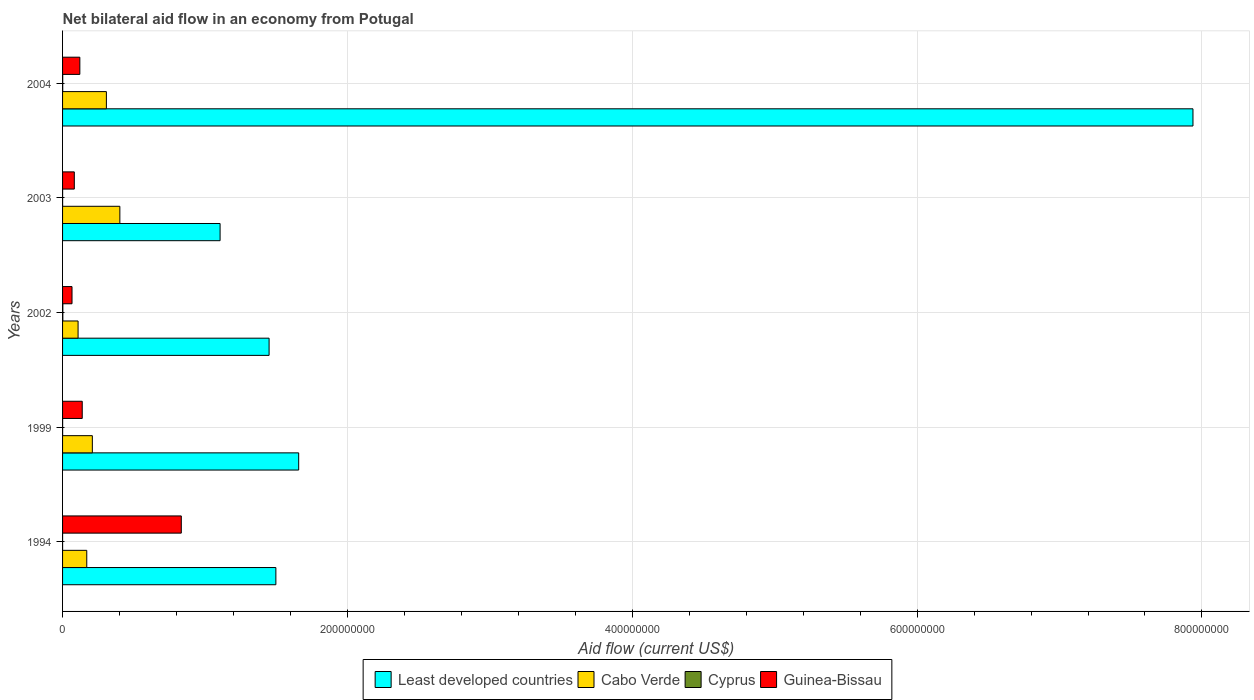How many groups of bars are there?
Give a very brief answer. 5. Are the number of bars per tick equal to the number of legend labels?
Ensure brevity in your answer.  Yes. Are the number of bars on each tick of the Y-axis equal?
Your answer should be very brief. Yes. How many bars are there on the 4th tick from the bottom?
Your response must be concise. 4. What is the label of the 1st group of bars from the top?
Provide a short and direct response. 2004. What is the net bilateral aid flow in Least developed countries in 2004?
Ensure brevity in your answer.  7.94e+08. Across all years, what is the maximum net bilateral aid flow in Cabo Verde?
Provide a short and direct response. 4.02e+07. Across all years, what is the minimum net bilateral aid flow in Least developed countries?
Make the answer very short. 1.11e+08. In which year was the net bilateral aid flow in Least developed countries maximum?
Your response must be concise. 2004. What is the difference between the net bilateral aid flow in Least developed countries in 2002 and that in 2003?
Give a very brief answer. 3.44e+07. What is the difference between the net bilateral aid flow in Guinea-Bissau in 1994 and the net bilateral aid flow in Least developed countries in 1999?
Your response must be concise. -8.24e+07. What is the average net bilateral aid flow in Least developed countries per year?
Keep it short and to the point. 2.73e+08. In the year 2002, what is the difference between the net bilateral aid flow in Guinea-Bissau and net bilateral aid flow in Cabo Verde?
Give a very brief answer. -4.25e+06. What is the ratio of the net bilateral aid flow in Cabo Verde in 1999 to that in 2003?
Provide a succinct answer. 0.52. Is the difference between the net bilateral aid flow in Guinea-Bissau in 1999 and 2003 greater than the difference between the net bilateral aid flow in Cabo Verde in 1999 and 2003?
Make the answer very short. Yes. What is the difference between the highest and the second highest net bilateral aid flow in Cyprus?
Make the answer very short. 8.00e+04. What is the difference between the highest and the lowest net bilateral aid flow in Guinea-Bissau?
Offer a very short reply. 7.67e+07. Is the sum of the net bilateral aid flow in Cabo Verde in 1999 and 2002 greater than the maximum net bilateral aid flow in Cyprus across all years?
Provide a short and direct response. Yes. Is it the case that in every year, the sum of the net bilateral aid flow in Least developed countries and net bilateral aid flow in Cyprus is greater than the sum of net bilateral aid flow in Guinea-Bissau and net bilateral aid flow in Cabo Verde?
Ensure brevity in your answer.  Yes. What does the 3rd bar from the top in 1999 represents?
Your answer should be compact. Cabo Verde. What does the 1st bar from the bottom in 2004 represents?
Provide a succinct answer. Least developed countries. Is it the case that in every year, the sum of the net bilateral aid flow in Cabo Verde and net bilateral aid flow in Cyprus is greater than the net bilateral aid flow in Least developed countries?
Provide a succinct answer. No. How many bars are there?
Offer a terse response. 20. Are all the bars in the graph horizontal?
Offer a terse response. Yes. How many years are there in the graph?
Provide a succinct answer. 5. Does the graph contain grids?
Your answer should be very brief. Yes. How are the legend labels stacked?
Ensure brevity in your answer.  Horizontal. What is the title of the graph?
Offer a terse response. Net bilateral aid flow in an economy from Potugal. Does "Cambodia" appear as one of the legend labels in the graph?
Keep it short and to the point. No. What is the label or title of the X-axis?
Make the answer very short. Aid flow (current US$). What is the label or title of the Y-axis?
Ensure brevity in your answer.  Years. What is the Aid flow (current US$) in Least developed countries in 1994?
Offer a very short reply. 1.50e+08. What is the Aid flow (current US$) of Cabo Verde in 1994?
Your response must be concise. 1.70e+07. What is the Aid flow (current US$) of Cyprus in 1994?
Provide a succinct answer. 10000. What is the Aid flow (current US$) in Guinea-Bissau in 1994?
Make the answer very short. 8.34e+07. What is the Aid flow (current US$) of Least developed countries in 1999?
Provide a succinct answer. 1.66e+08. What is the Aid flow (current US$) in Cabo Verde in 1999?
Make the answer very short. 2.09e+07. What is the Aid flow (current US$) in Cyprus in 1999?
Your response must be concise. 4.00e+04. What is the Aid flow (current US$) of Guinea-Bissau in 1999?
Keep it short and to the point. 1.38e+07. What is the Aid flow (current US$) of Least developed countries in 2002?
Ensure brevity in your answer.  1.45e+08. What is the Aid flow (current US$) in Cabo Verde in 2002?
Keep it short and to the point. 1.09e+07. What is the Aid flow (current US$) of Guinea-Bissau in 2002?
Your answer should be compact. 6.64e+06. What is the Aid flow (current US$) in Least developed countries in 2003?
Your response must be concise. 1.11e+08. What is the Aid flow (current US$) in Cabo Verde in 2003?
Keep it short and to the point. 4.02e+07. What is the Aid flow (current US$) in Cyprus in 2003?
Your answer should be very brief. 3.00e+04. What is the Aid flow (current US$) in Guinea-Bissau in 2003?
Your answer should be very brief. 8.25e+06. What is the Aid flow (current US$) in Least developed countries in 2004?
Make the answer very short. 7.94e+08. What is the Aid flow (current US$) of Cabo Verde in 2004?
Provide a succinct answer. 3.08e+07. What is the Aid flow (current US$) of Cyprus in 2004?
Your answer should be compact. 1.10e+05. What is the Aid flow (current US$) in Guinea-Bissau in 2004?
Your answer should be very brief. 1.21e+07. Across all years, what is the maximum Aid flow (current US$) in Least developed countries?
Provide a succinct answer. 7.94e+08. Across all years, what is the maximum Aid flow (current US$) in Cabo Verde?
Provide a succinct answer. 4.02e+07. Across all years, what is the maximum Aid flow (current US$) of Guinea-Bissau?
Your answer should be very brief. 8.34e+07. Across all years, what is the minimum Aid flow (current US$) in Least developed countries?
Provide a succinct answer. 1.11e+08. Across all years, what is the minimum Aid flow (current US$) in Cabo Verde?
Make the answer very short. 1.09e+07. Across all years, what is the minimum Aid flow (current US$) in Cyprus?
Provide a short and direct response. 10000. Across all years, what is the minimum Aid flow (current US$) of Guinea-Bissau?
Offer a very short reply. 6.64e+06. What is the total Aid flow (current US$) of Least developed countries in the graph?
Offer a terse response. 1.36e+09. What is the total Aid flow (current US$) of Cabo Verde in the graph?
Your response must be concise. 1.20e+08. What is the total Aid flow (current US$) in Cyprus in the graph?
Provide a short and direct response. 3.80e+05. What is the total Aid flow (current US$) of Guinea-Bissau in the graph?
Offer a terse response. 1.24e+08. What is the difference between the Aid flow (current US$) in Least developed countries in 1994 and that in 1999?
Provide a succinct answer. -1.60e+07. What is the difference between the Aid flow (current US$) in Cabo Verde in 1994 and that in 1999?
Make the answer very short. -3.92e+06. What is the difference between the Aid flow (current US$) in Guinea-Bissau in 1994 and that in 1999?
Your answer should be compact. 6.96e+07. What is the difference between the Aid flow (current US$) of Least developed countries in 1994 and that in 2002?
Provide a short and direct response. 4.76e+06. What is the difference between the Aid flow (current US$) in Cabo Verde in 1994 and that in 2002?
Offer a terse response. 6.10e+06. What is the difference between the Aid flow (current US$) of Cyprus in 1994 and that in 2002?
Provide a succinct answer. -1.80e+05. What is the difference between the Aid flow (current US$) in Guinea-Bissau in 1994 and that in 2002?
Keep it short and to the point. 7.67e+07. What is the difference between the Aid flow (current US$) in Least developed countries in 1994 and that in 2003?
Offer a very short reply. 3.92e+07. What is the difference between the Aid flow (current US$) in Cabo Verde in 1994 and that in 2003?
Provide a short and direct response. -2.32e+07. What is the difference between the Aid flow (current US$) of Guinea-Bissau in 1994 and that in 2003?
Give a very brief answer. 7.51e+07. What is the difference between the Aid flow (current US$) in Least developed countries in 1994 and that in 2004?
Ensure brevity in your answer.  -6.44e+08. What is the difference between the Aid flow (current US$) of Cabo Verde in 1994 and that in 2004?
Give a very brief answer. -1.38e+07. What is the difference between the Aid flow (current US$) of Guinea-Bissau in 1994 and that in 2004?
Offer a very short reply. 7.12e+07. What is the difference between the Aid flow (current US$) of Least developed countries in 1999 and that in 2002?
Offer a terse response. 2.08e+07. What is the difference between the Aid flow (current US$) in Cabo Verde in 1999 and that in 2002?
Give a very brief answer. 1.00e+07. What is the difference between the Aid flow (current US$) of Cyprus in 1999 and that in 2002?
Offer a terse response. -1.50e+05. What is the difference between the Aid flow (current US$) of Guinea-Bissau in 1999 and that in 2002?
Offer a very short reply. 7.17e+06. What is the difference between the Aid flow (current US$) of Least developed countries in 1999 and that in 2003?
Make the answer very short. 5.52e+07. What is the difference between the Aid flow (current US$) in Cabo Verde in 1999 and that in 2003?
Offer a very short reply. -1.93e+07. What is the difference between the Aid flow (current US$) in Guinea-Bissau in 1999 and that in 2003?
Make the answer very short. 5.56e+06. What is the difference between the Aid flow (current US$) of Least developed countries in 1999 and that in 2004?
Offer a very short reply. -6.28e+08. What is the difference between the Aid flow (current US$) in Cabo Verde in 1999 and that in 2004?
Ensure brevity in your answer.  -9.86e+06. What is the difference between the Aid flow (current US$) of Cyprus in 1999 and that in 2004?
Keep it short and to the point. -7.00e+04. What is the difference between the Aid flow (current US$) of Guinea-Bissau in 1999 and that in 2004?
Offer a terse response. 1.68e+06. What is the difference between the Aid flow (current US$) in Least developed countries in 2002 and that in 2003?
Keep it short and to the point. 3.44e+07. What is the difference between the Aid flow (current US$) in Cabo Verde in 2002 and that in 2003?
Your answer should be very brief. -2.93e+07. What is the difference between the Aid flow (current US$) in Cyprus in 2002 and that in 2003?
Make the answer very short. 1.60e+05. What is the difference between the Aid flow (current US$) of Guinea-Bissau in 2002 and that in 2003?
Your response must be concise. -1.61e+06. What is the difference between the Aid flow (current US$) of Least developed countries in 2002 and that in 2004?
Your answer should be compact. -6.49e+08. What is the difference between the Aid flow (current US$) in Cabo Verde in 2002 and that in 2004?
Your answer should be very brief. -1.99e+07. What is the difference between the Aid flow (current US$) in Cyprus in 2002 and that in 2004?
Give a very brief answer. 8.00e+04. What is the difference between the Aid flow (current US$) of Guinea-Bissau in 2002 and that in 2004?
Your answer should be very brief. -5.49e+06. What is the difference between the Aid flow (current US$) in Least developed countries in 2003 and that in 2004?
Offer a terse response. -6.83e+08. What is the difference between the Aid flow (current US$) in Cabo Verde in 2003 and that in 2004?
Ensure brevity in your answer.  9.46e+06. What is the difference between the Aid flow (current US$) of Cyprus in 2003 and that in 2004?
Provide a succinct answer. -8.00e+04. What is the difference between the Aid flow (current US$) of Guinea-Bissau in 2003 and that in 2004?
Keep it short and to the point. -3.88e+06. What is the difference between the Aid flow (current US$) of Least developed countries in 1994 and the Aid flow (current US$) of Cabo Verde in 1999?
Provide a short and direct response. 1.29e+08. What is the difference between the Aid flow (current US$) of Least developed countries in 1994 and the Aid flow (current US$) of Cyprus in 1999?
Keep it short and to the point. 1.50e+08. What is the difference between the Aid flow (current US$) of Least developed countries in 1994 and the Aid flow (current US$) of Guinea-Bissau in 1999?
Offer a terse response. 1.36e+08. What is the difference between the Aid flow (current US$) of Cabo Verde in 1994 and the Aid flow (current US$) of Cyprus in 1999?
Your answer should be very brief. 1.70e+07. What is the difference between the Aid flow (current US$) of Cabo Verde in 1994 and the Aid flow (current US$) of Guinea-Bissau in 1999?
Your response must be concise. 3.18e+06. What is the difference between the Aid flow (current US$) of Cyprus in 1994 and the Aid flow (current US$) of Guinea-Bissau in 1999?
Your answer should be very brief. -1.38e+07. What is the difference between the Aid flow (current US$) of Least developed countries in 1994 and the Aid flow (current US$) of Cabo Verde in 2002?
Keep it short and to the point. 1.39e+08. What is the difference between the Aid flow (current US$) in Least developed countries in 1994 and the Aid flow (current US$) in Cyprus in 2002?
Your answer should be compact. 1.50e+08. What is the difference between the Aid flow (current US$) in Least developed countries in 1994 and the Aid flow (current US$) in Guinea-Bissau in 2002?
Provide a succinct answer. 1.43e+08. What is the difference between the Aid flow (current US$) in Cabo Verde in 1994 and the Aid flow (current US$) in Cyprus in 2002?
Your answer should be compact. 1.68e+07. What is the difference between the Aid flow (current US$) in Cabo Verde in 1994 and the Aid flow (current US$) in Guinea-Bissau in 2002?
Give a very brief answer. 1.04e+07. What is the difference between the Aid flow (current US$) of Cyprus in 1994 and the Aid flow (current US$) of Guinea-Bissau in 2002?
Make the answer very short. -6.63e+06. What is the difference between the Aid flow (current US$) of Least developed countries in 1994 and the Aid flow (current US$) of Cabo Verde in 2003?
Your response must be concise. 1.10e+08. What is the difference between the Aid flow (current US$) of Least developed countries in 1994 and the Aid flow (current US$) of Cyprus in 2003?
Give a very brief answer. 1.50e+08. What is the difference between the Aid flow (current US$) in Least developed countries in 1994 and the Aid flow (current US$) in Guinea-Bissau in 2003?
Your answer should be very brief. 1.42e+08. What is the difference between the Aid flow (current US$) in Cabo Verde in 1994 and the Aid flow (current US$) in Cyprus in 2003?
Keep it short and to the point. 1.70e+07. What is the difference between the Aid flow (current US$) in Cabo Verde in 1994 and the Aid flow (current US$) in Guinea-Bissau in 2003?
Your response must be concise. 8.74e+06. What is the difference between the Aid flow (current US$) of Cyprus in 1994 and the Aid flow (current US$) of Guinea-Bissau in 2003?
Ensure brevity in your answer.  -8.24e+06. What is the difference between the Aid flow (current US$) of Least developed countries in 1994 and the Aid flow (current US$) of Cabo Verde in 2004?
Your answer should be compact. 1.19e+08. What is the difference between the Aid flow (current US$) in Least developed countries in 1994 and the Aid flow (current US$) in Cyprus in 2004?
Make the answer very short. 1.50e+08. What is the difference between the Aid flow (current US$) in Least developed countries in 1994 and the Aid flow (current US$) in Guinea-Bissau in 2004?
Your answer should be very brief. 1.38e+08. What is the difference between the Aid flow (current US$) in Cabo Verde in 1994 and the Aid flow (current US$) in Cyprus in 2004?
Offer a terse response. 1.69e+07. What is the difference between the Aid flow (current US$) in Cabo Verde in 1994 and the Aid flow (current US$) in Guinea-Bissau in 2004?
Offer a terse response. 4.86e+06. What is the difference between the Aid flow (current US$) in Cyprus in 1994 and the Aid flow (current US$) in Guinea-Bissau in 2004?
Your answer should be very brief. -1.21e+07. What is the difference between the Aid flow (current US$) in Least developed countries in 1999 and the Aid flow (current US$) in Cabo Verde in 2002?
Ensure brevity in your answer.  1.55e+08. What is the difference between the Aid flow (current US$) of Least developed countries in 1999 and the Aid flow (current US$) of Cyprus in 2002?
Make the answer very short. 1.66e+08. What is the difference between the Aid flow (current US$) of Least developed countries in 1999 and the Aid flow (current US$) of Guinea-Bissau in 2002?
Keep it short and to the point. 1.59e+08. What is the difference between the Aid flow (current US$) of Cabo Verde in 1999 and the Aid flow (current US$) of Cyprus in 2002?
Offer a very short reply. 2.07e+07. What is the difference between the Aid flow (current US$) in Cabo Verde in 1999 and the Aid flow (current US$) in Guinea-Bissau in 2002?
Ensure brevity in your answer.  1.43e+07. What is the difference between the Aid flow (current US$) of Cyprus in 1999 and the Aid flow (current US$) of Guinea-Bissau in 2002?
Keep it short and to the point. -6.60e+06. What is the difference between the Aid flow (current US$) in Least developed countries in 1999 and the Aid flow (current US$) in Cabo Verde in 2003?
Keep it short and to the point. 1.26e+08. What is the difference between the Aid flow (current US$) of Least developed countries in 1999 and the Aid flow (current US$) of Cyprus in 2003?
Offer a terse response. 1.66e+08. What is the difference between the Aid flow (current US$) of Least developed countries in 1999 and the Aid flow (current US$) of Guinea-Bissau in 2003?
Your answer should be compact. 1.58e+08. What is the difference between the Aid flow (current US$) of Cabo Verde in 1999 and the Aid flow (current US$) of Cyprus in 2003?
Your answer should be very brief. 2.09e+07. What is the difference between the Aid flow (current US$) of Cabo Verde in 1999 and the Aid flow (current US$) of Guinea-Bissau in 2003?
Offer a terse response. 1.27e+07. What is the difference between the Aid flow (current US$) of Cyprus in 1999 and the Aid flow (current US$) of Guinea-Bissau in 2003?
Give a very brief answer. -8.21e+06. What is the difference between the Aid flow (current US$) in Least developed countries in 1999 and the Aid flow (current US$) in Cabo Verde in 2004?
Ensure brevity in your answer.  1.35e+08. What is the difference between the Aid flow (current US$) in Least developed countries in 1999 and the Aid flow (current US$) in Cyprus in 2004?
Offer a very short reply. 1.66e+08. What is the difference between the Aid flow (current US$) in Least developed countries in 1999 and the Aid flow (current US$) in Guinea-Bissau in 2004?
Make the answer very short. 1.54e+08. What is the difference between the Aid flow (current US$) in Cabo Verde in 1999 and the Aid flow (current US$) in Cyprus in 2004?
Ensure brevity in your answer.  2.08e+07. What is the difference between the Aid flow (current US$) of Cabo Verde in 1999 and the Aid flow (current US$) of Guinea-Bissau in 2004?
Make the answer very short. 8.78e+06. What is the difference between the Aid flow (current US$) in Cyprus in 1999 and the Aid flow (current US$) in Guinea-Bissau in 2004?
Make the answer very short. -1.21e+07. What is the difference between the Aid flow (current US$) in Least developed countries in 2002 and the Aid flow (current US$) in Cabo Verde in 2003?
Make the answer very short. 1.05e+08. What is the difference between the Aid flow (current US$) of Least developed countries in 2002 and the Aid flow (current US$) of Cyprus in 2003?
Provide a short and direct response. 1.45e+08. What is the difference between the Aid flow (current US$) in Least developed countries in 2002 and the Aid flow (current US$) in Guinea-Bissau in 2003?
Provide a short and direct response. 1.37e+08. What is the difference between the Aid flow (current US$) of Cabo Verde in 2002 and the Aid flow (current US$) of Cyprus in 2003?
Provide a succinct answer. 1.09e+07. What is the difference between the Aid flow (current US$) of Cabo Verde in 2002 and the Aid flow (current US$) of Guinea-Bissau in 2003?
Make the answer very short. 2.64e+06. What is the difference between the Aid flow (current US$) in Cyprus in 2002 and the Aid flow (current US$) in Guinea-Bissau in 2003?
Give a very brief answer. -8.06e+06. What is the difference between the Aid flow (current US$) in Least developed countries in 2002 and the Aid flow (current US$) in Cabo Verde in 2004?
Your response must be concise. 1.14e+08. What is the difference between the Aid flow (current US$) of Least developed countries in 2002 and the Aid flow (current US$) of Cyprus in 2004?
Your answer should be compact. 1.45e+08. What is the difference between the Aid flow (current US$) in Least developed countries in 2002 and the Aid flow (current US$) in Guinea-Bissau in 2004?
Offer a very short reply. 1.33e+08. What is the difference between the Aid flow (current US$) of Cabo Verde in 2002 and the Aid flow (current US$) of Cyprus in 2004?
Make the answer very short. 1.08e+07. What is the difference between the Aid flow (current US$) in Cabo Verde in 2002 and the Aid flow (current US$) in Guinea-Bissau in 2004?
Ensure brevity in your answer.  -1.24e+06. What is the difference between the Aid flow (current US$) in Cyprus in 2002 and the Aid flow (current US$) in Guinea-Bissau in 2004?
Ensure brevity in your answer.  -1.19e+07. What is the difference between the Aid flow (current US$) of Least developed countries in 2003 and the Aid flow (current US$) of Cabo Verde in 2004?
Make the answer very short. 7.98e+07. What is the difference between the Aid flow (current US$) of Least developed countries in 2003 and the Aid flow (current US$) of Cyprus in 2004?
Keep it short and to the point. 1.10e+08. What is the difference between the Aid flow (current US$) in Least developed countries in 2003 and the Aid flow (current US$) in Guinea-Bissau in 2004?
Give a very brief answer. 9.85e+07. What is the difference between the Aid flow (current US$) in Cabo Verde in 2003 and the Aid flow (current US$) in Cyprus in 2004?
Provide a short and direct response. 4.01e+07. What is the difference between the Aid flow (current US$) in Cabo Verde in 2003 and the Aid flow (current US$) in Guinea-Bissau in 2004?
Give a very brief answer. 2.81e+07. What is the difference between the Aid flow (current US$) in Cyprus in 2003 and the Aid flow (current US$) in Guinea-Bissau in 2004?
Give a very brief answer. -1.21e+07. What is the average Aid flow (current US$) of Least developed countries per year?
Provide a short and direct response. 2.73e+08. What is the average Aid flow (current US$) of Cabo Verde per year?
Provide a short and direct response. 2.40e+07. What is the average Aid flow (current US$) of Cyprus per year?
Offer a very short reply. 7.60e+04. What is the average Aid flow (current US$) of Guinea-Bissau per year?
Ensure brevity in your answer.  2.48e+07. In the year 1994, what is the difference between the Aid flow (current US$) in Least developed countries and Aid flow (current US$) in Cabo Verde?
Make the answer very short. 1.33e+08. In the year 1994, what is the difference between the Aid flow (current US$) of Least developed countries and Aid flow (current US$) of Cyprus?
Your answer should be compact. 1.50e+08. In the year 1994, what is the difference between the Aid flow (current US$) in Least developed countries and Aid flow (current US$) in Guinea-Bissau?
Make the answer very short. 6.64e+07. In the year 1994, what is the difference between the Aid flow (current US$) of Cabo Verde and Aid flow (current US$) of Cyprus?
Provide a succinct answer. 1.70e+07. In the year 1994, what is the difference between the Aid flow (current US$) of Cabo Verde and Aid flow (current US$) of Guinea-Bissau?
Your response must be concise. -6.64e+07. In the year 1994, what is the difference between the Aid flow (current US$) of Cyprus and Aid flow (current US$) of Guinea-Bissau?
Keep it short and to the point. -8.34e+07. In the year 1999, what is the difference between the Aid flow (current US$) in Least developed countries and Aid flow (current US$) in Cabo Verde?
Keep it short and to the point. 1.45e+08. In the year 1999, what is the difference between the Aid flow (current US$) in Least developed countries and Aid flow (current US$) in Cyprus?
Your response must be concise. 1.66e+08. In the year 1999, what is the difference between the Aid flow (current US$) in Least developed countries and Aid flow (current US$) in Guinea-Bissau?
Keep it short and to the point. 1.52e+08. In the year 1999, what is the difference between the Aid flow (current US$) of Cabo Verde and Aid flow (current US$) of Cyprus?
Your answer should be compact. 2.09e+07. In the year 1999, what is the difference between the Aid flow (current US$) of Cabo Verde and Aid flow (current US$) of Guinea-Bissau?
Offer a terse response. 7.10e+06. In the year 1999, what is the difference between the Aid flow (current US$) of Cyprus and Aid flow (current US$) of Guinea-Bissau?
Offer a very short reply. -1.38e+07. In the year 2002, what is the difference between the Aid flow (current US$) in Least developed countries and Aid flow (current US$) in Cabo Verde?
Make the answer very short. 1.34e+08. In the year 2002, what is the difference between the Aid flow (current US$) in Least developed countries and Aid flow (current US$) in Cyprus?
Offer a terse response. 1.45e+08. In the year 2002, what is the difference between the Aid flow (current US$) in Least developed countries and Aid flow (current US$) in Guinea-Bissau?
Ensure brevity in your answer.  1.38e+08. In the year 2002, what is the difference between the Aid flow (current US$) in Cabo Verde and Aid flow (current US$) in Cyprus?
Make the answer very short. 1.07e+07. In the year 2002, what is the difference between the Aid flow (current US$) in Cabo Verde and Aid flow (current US$) in Guinea-Bissau?
Provide a short and direct response. 4.25e+06. In the year 2002, what is the difference between the Aid flow (current US$) in Cyprus and Aid flow (current US$) in Guinea-Bissau?
Your answer should be compact. -6.45e+06. In the year 2003, what is the difference between the Aid flow (current US$) of Least developed countries and Aid flow (current US$) of Cabo Verde?
Provide a short and direct response. 7.04e+07. In the year 2003, what is the difference between the Aid flow (current US$) of Least developed countries and Aid flow (current US$) of Cyprus?
Make the answer very short. 1.11e+08. In the year 2003, what is the difference between the Aid flow (current US$) of Least developed countries and Aid flow (current US$) of Guinea-Bissau?
Make the answer very short. 1.02e+08. In the year 2003, what is the difference between the Aid flow (current US$) in Cabo Verde and Aid flow (current US$) in Cyprus?
Give a very brief answer. 4.02e+07. In the year 2003, what is the difference between the Aid flow (current US$) of Cabo Verde and Aid flow (current US$) of Guinea-Bissau?
Keep it short and to the point. 3.20e+07. In the year 2003, what is the difference between the Aid flow (current US$) in Cyprus and Aid flow (current US$) in Guinea-Bissau?
Keep it short and to the point. -8.22e+06. In the year 2004, what is the difference between the Aid flow (current US$) of Least developed countries and Aid flow (current US$) of Cabo Verde?
Your answer should be very brief. 7.63e+08. In the year 2004, what is the difference between the Aid flow (current US$) of Least developed countries and Aid flow (current US$) of Cyprus?
Your response must be concise. 7.94e+08. In the year 2004, what is the difference between the Aid flow (current US$) in Least developed countries and Aid flow (current US$) in Guinea-Bissau?
Make the answer very short. 7.82e+08. In the year 2004, what is the difference between the Aid flow (current US$) in Cabo Verde and Aid flow (current US$) in Cyprus?
Offer a very short reply. 3.07e+07. In the year 2004, what is the difference between the Aid flow (current US$) of Cabo Verde and Aid flow (current US$) of Guinea-Bissau?
Ensure brevity in your answer.  1.86e+07. In the year 2004, what is the difference between the Aid flow (current US$) in Cyprus and Aid flow (current US$) in Guinea-Bissau?
Ensure brevity in your answer.  -1.20e+07. What is the ratio of the Aid flow (current US$) of Least developed countries in 1994 to that in 1999?
Your answer should be compact. 0.9. What is the ratio of the Aid flow (current US$) of Cabo Verde in 1994 to that in 1999?
Provide a succinct answer. 0.81. What is the ratio of the Aid flow (current US$) of Cyprus in 1994 to that in 1999?
Give a very brief answer. 0.25. What is the ratio of the Aid flow (current US$) in Guinea-Bissau in 1994 to that in 1999?
Provide a succinct answer. 6.04. What is the ratio of the Aid flow (current US$) of Least developed countries in 1994 to that in 2002?
Keep it short and to the point. 1.03. What is the ratio of the Aid flow (current US$) of Cabo Verde in 1994 to that in 2002?
Keep it short and to the point. 1.56. What is the ratio of the Aid flow (current US$) in Cyprus in 1994 to that in 2002?
Your answer should be very brief. 0.05. What is the ratio of the Aid flow (current US$) of Guinea-Bissau in 1994 to that in 2002?
Provide a succinct answer. 12.56. What is the ratio of the Aid flow (current US$) of Least developed countries in 1994 to that in 2003?
Give a very brief answer. 1.35. What is the ratio of the Aid flow (current US$) of Cabo Verde in 1994 to that in 2003?
Your answer should be very brief. 0.42. What is the ratio of the Aid flow (current US$) in Cyprus in 1994 to that in 2003?
Your response must be concise. 0.33. What is the ratio of the Aid flow (current US$) in Guinea-Bissau in 1994 to that in 2003?
Give a very brief answer. 10.11. What is the ratio of the Aid flow (current US$) of Least developed countries in 1994 to that in 2004?
Ensure brevity in your answer.  0.19. What is the ratio of the Aid flow (current US$) in Cabo Verde in 1994 to that in 2004?
Your answer should be compact. 0.55. What is the ratio of the Aid flow (current US$) of Cyprus in 1994 to that in 2004?
Give a very brief answer. 0.09. What is the ratio of the Aid flow (current US$) in Guinea-Bissau in 1994 to that in 2004?
Give a very brief answer. 6.87. What is the ratio of the Aid flow (current US$) in Least developed countries in 1999 to that in 2002?
Make the answer very short. 1.14. What is the ratio of the Aid flow (current US$) of Cabo Verde in 1999 to that in 2002?
Keep it short and to the point. 1.92. What is the ratio of the Aid flow (current US$) of Cyprus in 1999 to that in 2002?
Your answer should be very brief. 0.21. What is the ratio of the Aid flow (current US$) in Guinea-Bissau in 1999 to that in 2002?
Make the answer very short. 2.08. What is the ratio of the Aid flow (current US$) of Least developed countries in 1999 to that in 2003?
Ensure brevity in your answer.  1.5. What is the ratio of the Aid flow (current US$) of Cabo Verde in 1999 to that in 2003?
Provide a short and direct response. 0.52. What is the ratio of the Aid flow (current US$) of Cyprus in 1999 to that in 2003?
Offer a very short reply. 1.33. What is the ratio of the Aid flow (current US$) in Guinea-Bissau in 1999 to that in 2003?
Your response must be concise. 1.67. What is the ratio of the Aid flow (current US$) of Least developed countries in 1999 to that in 2004?
Give a very brief answer. 0.21. What is the ratio of the Aid flow (current US$) of Cabo Verde in 1999 to that in 2004?
Your response must be concise. 0.68. What is the ratio of the Aid flow (current US$) of Cyprus in 1999 to that in 2004?
Give a very brief answer. 0.36. What is the ratio of the Aid flow (current US$) in Guinea-Bissau in 1999 to that in 2004?
Give a very brief answer. 1.14. What is the ratio of the Aid flow (current US$) in Least developed countries in 2002 to that in 2003?
Your answer should be very brief. 1.31. What is the ratio of the Aid flow (current US$) in Cabo Verde in 2002 to that in 2003?
Ensure brevity in your answer.  0.27. What is the ratio of the Aid flow (current US$) of Cyprus in 2002 to that in 2003?
Your response must be concise. 6.33. What is the ratio of the Aid flow (current US$) of Guinea-Bissau in 2002 to that in 2003?
Keep it short and to the point. 0.8. What is the ratio of the Aid flow (current US$) of Least developed countries in 2002 to that in 2004?
Keep it short and to the point. 0.18. What is the ratio of the Aid flow (current US$) in Cabo Verde in 2002 to that in 2004?
Provide a short and direct response. 0.35. What is the ratio of the Aid flow (current US$) of Cyprus in 2002 to that in 2004?
Keep it short and to the point. 1.73. What is the ratio of the Aid flow (current US$) of Guinea-Bissau in 2002 to that in 2004?
Keep it short and to the point. 0.55. What is the ratio of the Aid flow (current US$) in Least developed countries in 2003 to that in 2004?
Provide a short and direct response. 0.14. What is the ratio of the Aid flow (current US$) of Cabo Verde in 2003 to that in 2004?
Give a very brief answer. 1.31. What is the ratio of the Aid flow (current US$) of Cyprus in 2003 to that in 2004?
Ensure brevity in your answer.  0.27. What is the ratio of the Aid flow (current US$) in Guinea-Bissau in 2003 to that in 2004?
Ensure brevity in your answer.  0.68. What is the difference between the highest and the second highest Aid flow (current US$) in Least developed countries?
Offer a terse response. 6.28e+08. What is the difference between the highest and the second highest Aid flow (current US$) of Cabo Verde?
Your answer should be compact. 9.46e+06. What is the difference between the highest and the second highest Aid flow (current US$) of Guinea-Bissau?
Your answer should be compact. 6.96e+07. What is the difference between the highest and the lowest Aid flow (current US$) of Least developed countries?
Make the answer very short. 6.83e+08. What is the difference between the highest and the lowest Aid flow (current US$) of Cabo Verde?
Your answer should be very brief. 2.93e+07. What is the difference between the highest and the lowest Aid flow (current US$) of Cyprus?
Give a very brief answer. 1.80e+05. What is the difference between the highest and the lowest Aid flow (current US$) in Guinea-Bissau?
Give a very brief answer. 7.67e+07. 